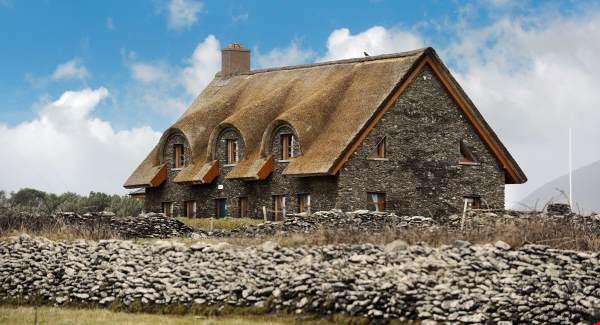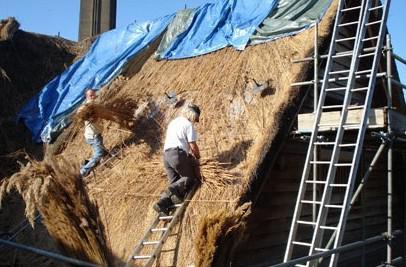The first image is the image on the left, the second image is the image on the right. Considering the images on both sides, is "The left image features a simple peaked thatch roof with a small projection at the top, and the right image features at least one animal figure on the edge of a peaked roof with diamond 'stitched' border." valid? Answer yes or no. No. The first image is the image on the left, the second image is the image on the right. Evaluate the accuracy of this statement regarding the images: "At least one animal is standing on the roof in the image on the right.". Is it true? Answer yes or no. No. 